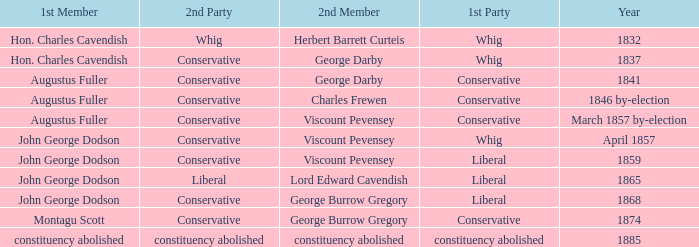In 1865, what was the first party? Liberal. 